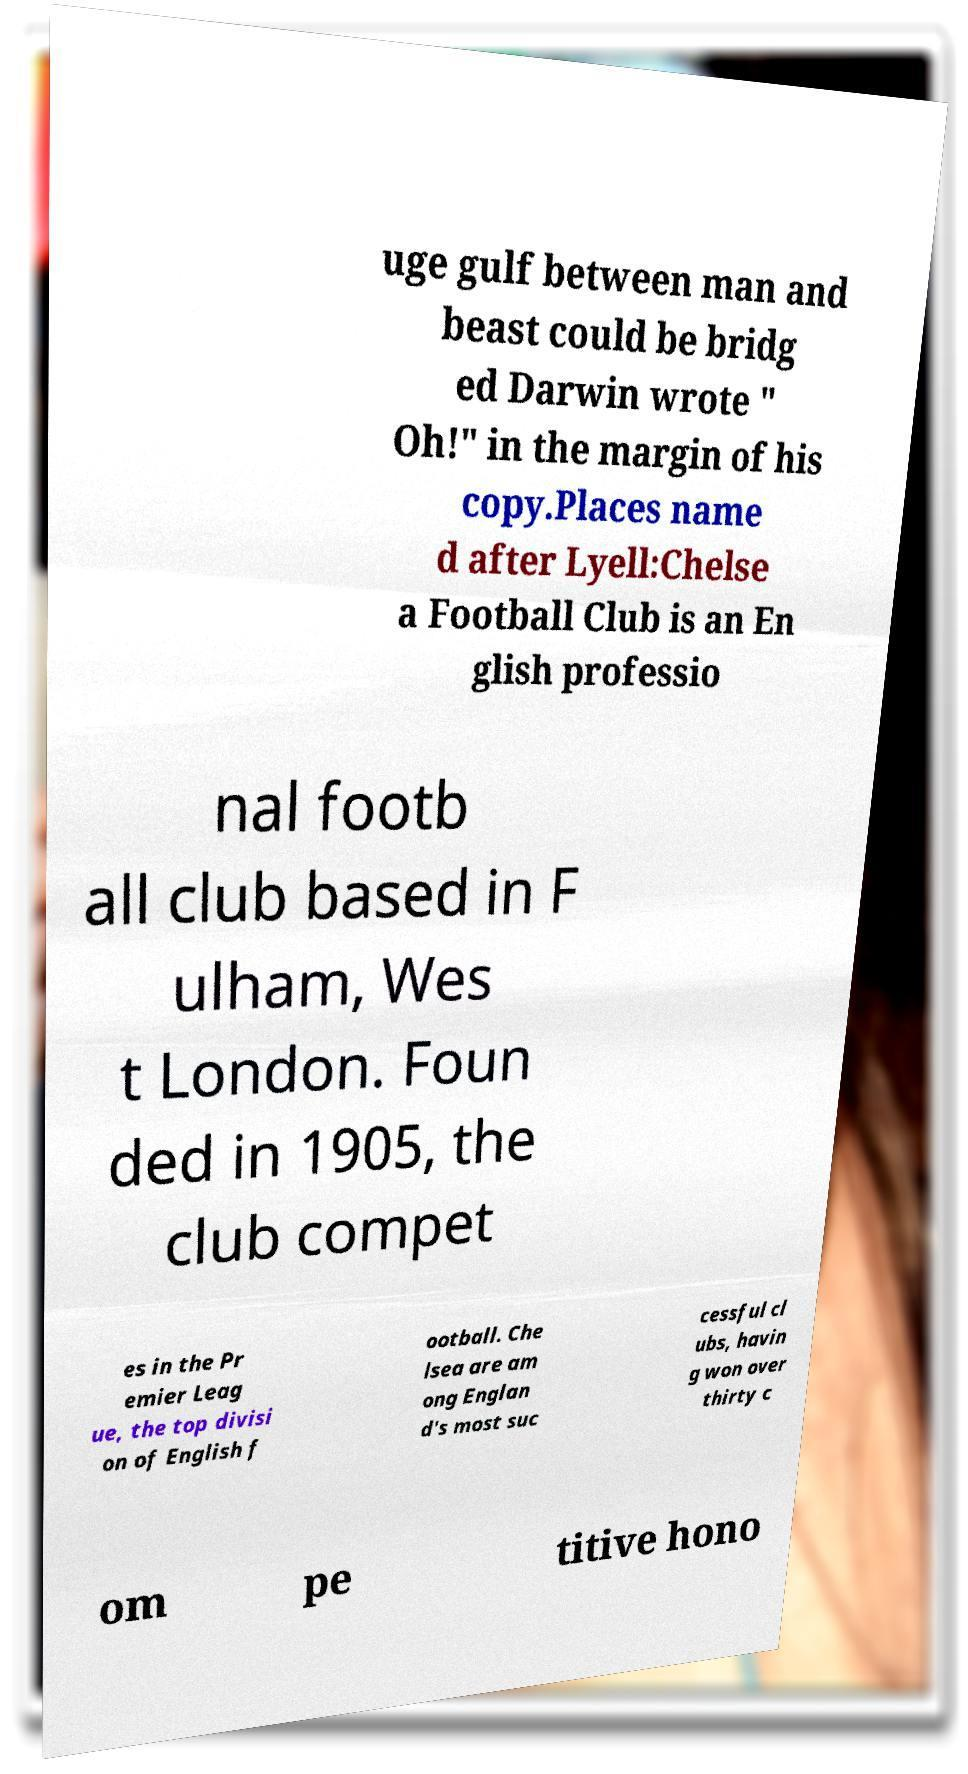Please read and relay the text visible in this image. What does it say? uge gulf between man and beast could be bridg ed Darwin wrote " Oh!" in the margin of his copy.Places name d after Lyell:Chelse a Football Club is an En glish professio nal footb all club based in F ulham, Wes t London. Foun ded in 1905, the club compet es in the Pr emier Leag ue, the top divisi on of English f ootball. Che lsea are am ong Englan d's most suc cessful cl ubs, havin g won over thirty c om pe titive hono 